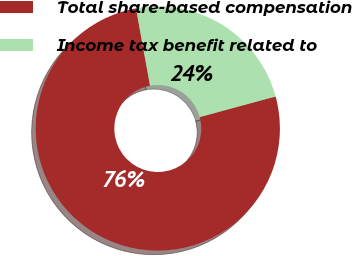Convert chart. <chart><loc_0><loc_0><loc_500><loc_500><pie_chart><fcel>Total share-based compensation<fcel>Income tax benefit related to<nl><fcel>76.37%<fcel>23.63%<nl></chart> 